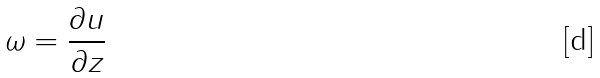<formula> <loc_0><loc_0><loc_500><loc_500>\omega = \frac { \partial u } { \partial z }</formula> 